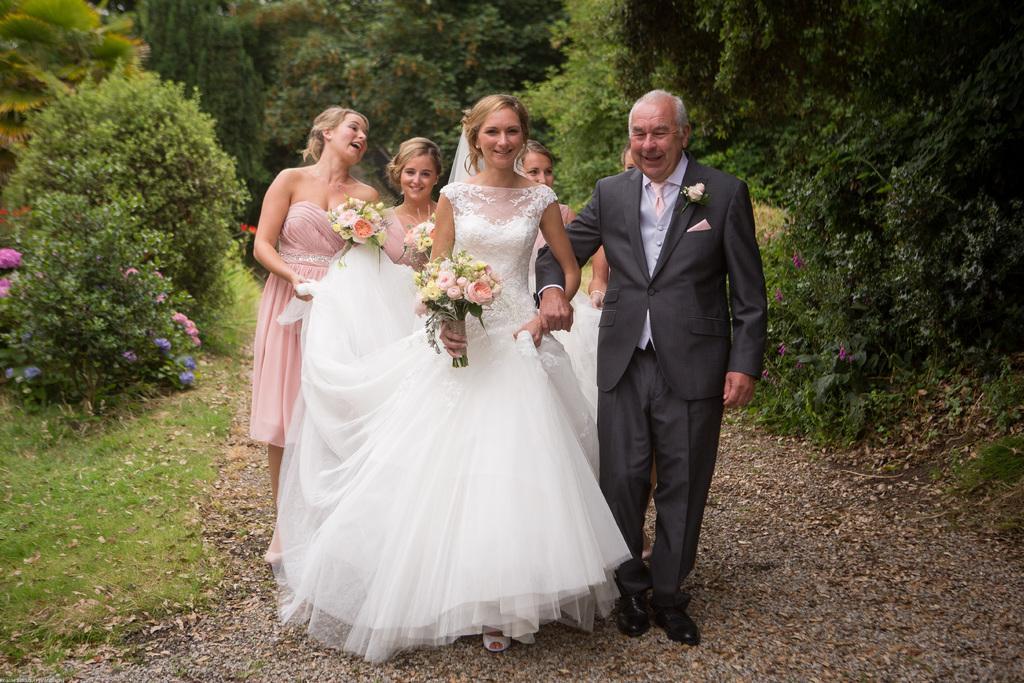Describe this image in one or two sentences. In this image we can see a man wearing the suit. We can also see the woman smiling and also holding the bouquets. In the background we can see the plants, trees, grass and at the bottom we can see the dried leaves. 